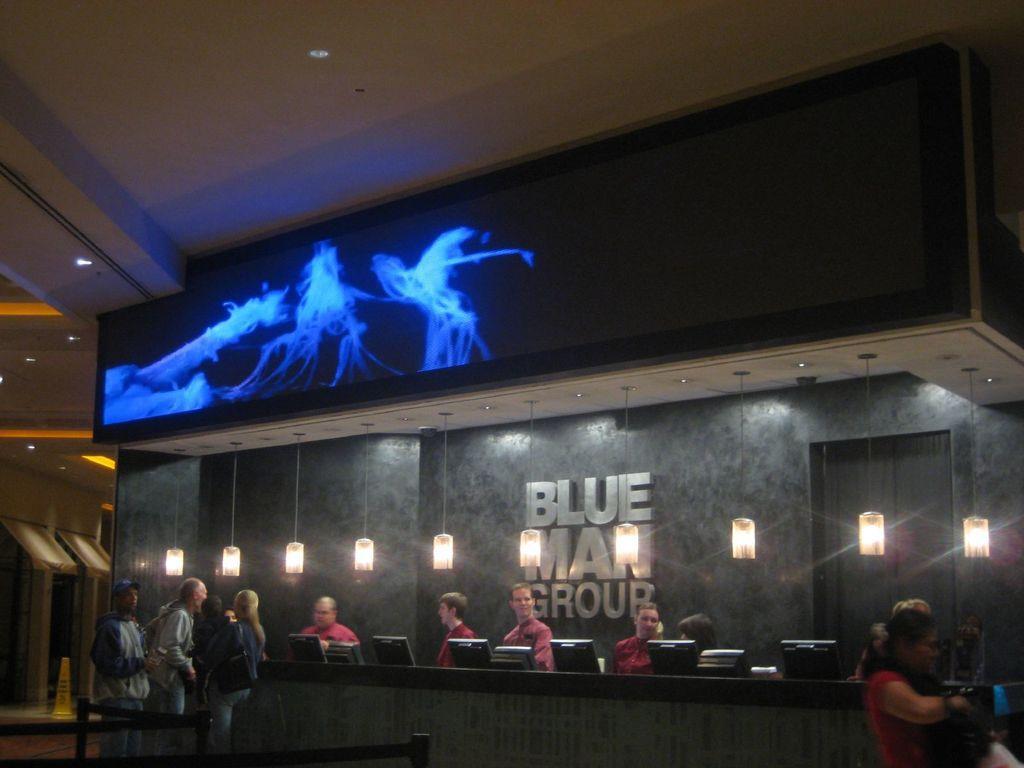In one or two sentences, can you explain what this image depicts? In this image, we can see people standing and there are desktops on the table. In the background, we can see lights. At the top, there is screen. 